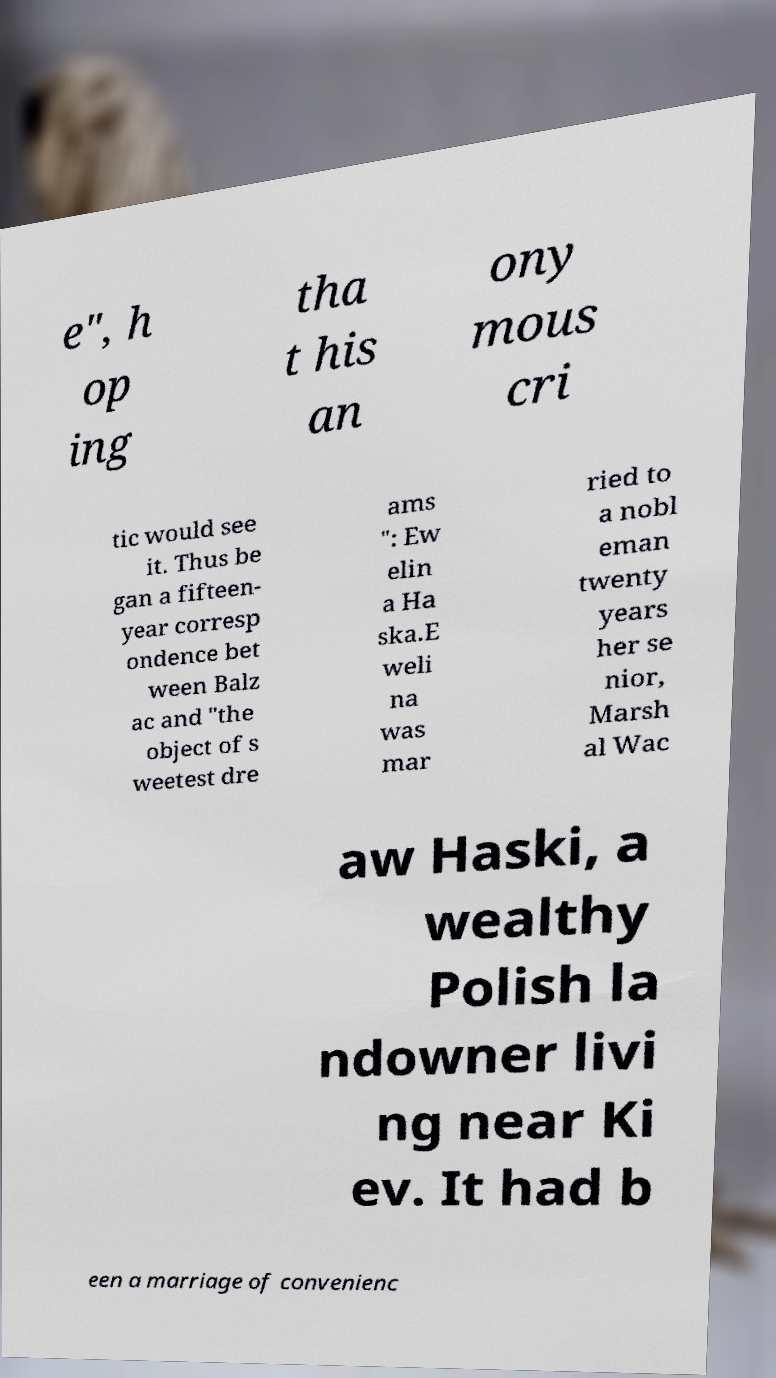Please read and relay the text visible in this image. What does it say? e", h op ing tha t his an ony mous cri tic would see it. Thus be gan a fifteen- year corresp ondence bet ween Balz ac and "the object of s weetest dre ams ": Ew elin a Ha ska.E weli na was mar ried to a nobl eman twenty years her se nior, Marsh al Wac aw Haski, a wealthy Polish la ndowner livi ng near Ki ev. It had b een a marriage of convenienc 